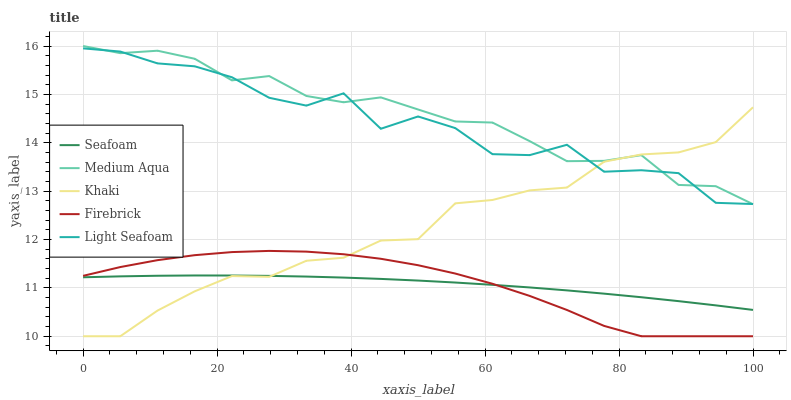Does Seafoam have the minimum area under the curve?
Answer yes or no. Yes. Does Medium Aqua have the maximum area under the curve?
Answer yes or no. Yes. Does Khaki have the minimum area under the curve?
Answer yes or no. No. Does Khaki have the maximum area under the curve?
Answer yes or no. No. Is Seafoam the smoothest?
Answer yes or no. Yes. Is Light Seafoam the roughest?
Answer yes or no. Yes. Is Khaki the smoothest?
Answer yes or no. No. Is Khaki the roughest?
Answer yes or no. No. Does Firebrick have the lowest value?
Answer yes or no. Yes. Does Medium Aqua have the lowest value?
Answer yes or no. No. Does Medium Aqua have the highest value?
Answer yes or no. Yes. Does Khaki have the highest value?
Answer yes or no. No. Is Seafoam less than Light Seafoam?
Answer yes or no. Yes. Is Light Seafoam greater than Firebrick?
Answer yes or no. Yes. Does Firebrick intersect Khaki?
Answer yes or no. Yes. Is Firebrick less than Khaki?
Answer yes or no. No. Is Firebrick greater than Khaki?
Answer yes or no. No. Does Seafoam intersect Light Seafoam?
Answer yes or no. No. 